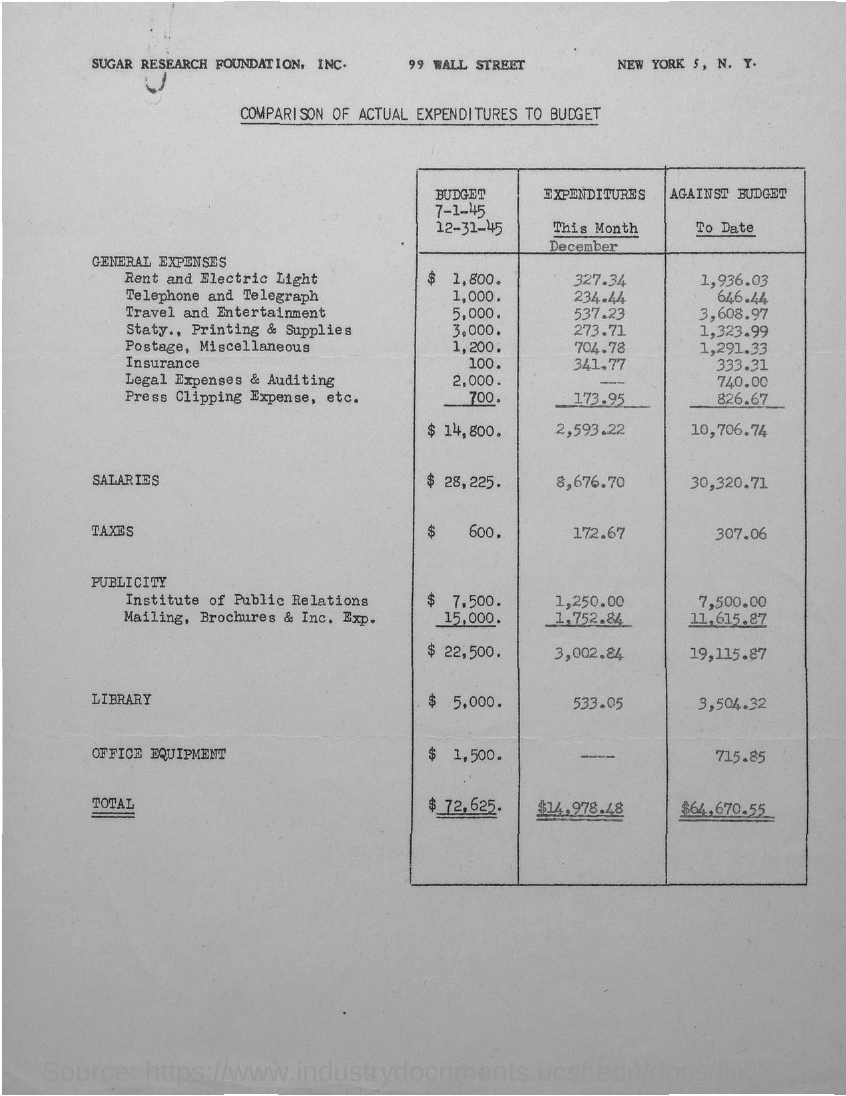Which city is sugar research foudation in?
Ensure brevity in your answer.  New york. How much is the budget for rent and electric light?
Your answer should be very brief. $1,800. How much is the expenditure for telephone and telegraph?
Your answer should be compact. 234.44. How much is the total budget?
Provide a short and direct response. $72,625. 